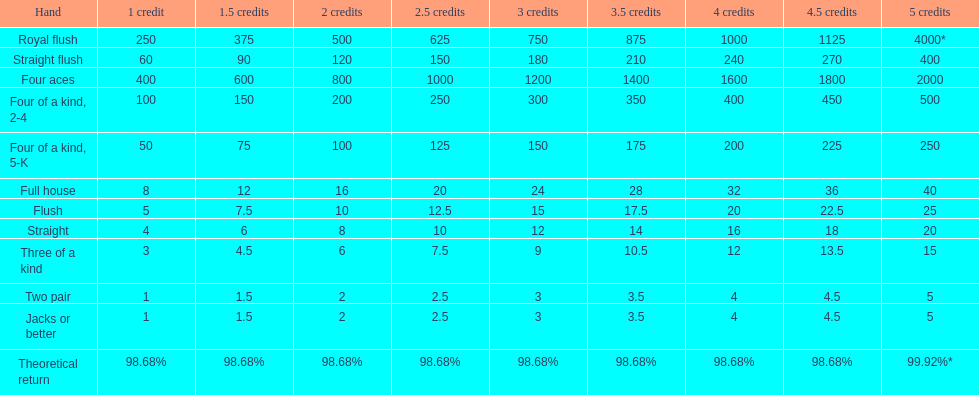How many straight wins at 3 credits equals one straight flush win at two credits? 10. 